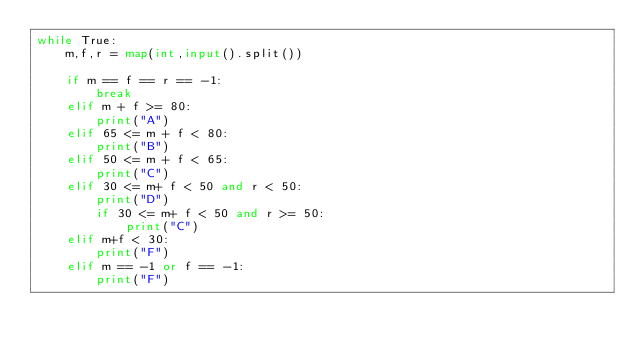<code> <loc_0><loc_0><loc_500><loc_500><_Python_>while True:
    m,f,r = map(int,input().split())
    
    if m == f == r == -1:
        break
    elif m + f >= 80:
        print("A")
    elif 65 <= m + f < 80:
        print("B")
    elif 50 <= m + f < 65:
        print("C")
    elif 30 <= m+ f < 50 and r < 50:
        print("D")
        if 30 <= m+ f < 50 and r >= 50:
            print("C")
    elif m+f < 30:
        print("F")
    elif m == -1 or f == -1:
        print("F")
</code> 